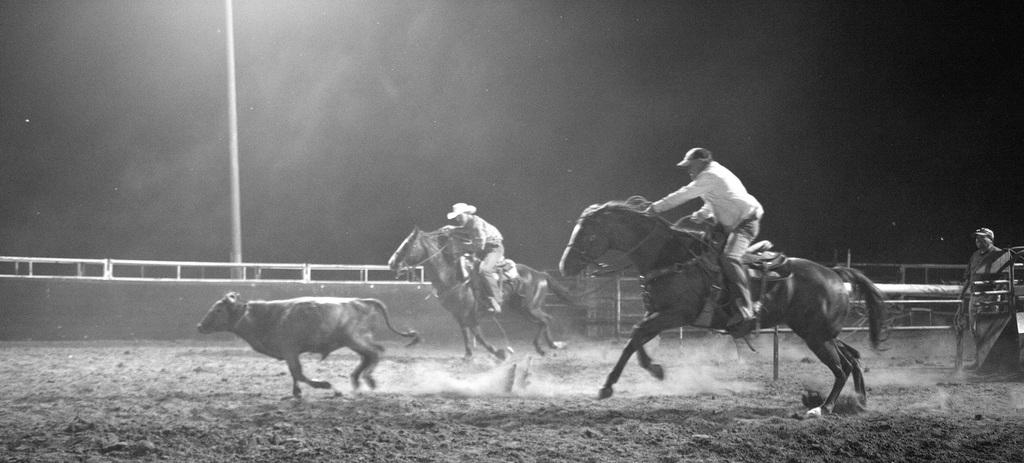What are the two persons in the image doing? The two persons in the image are riding horses. What can be seen beneath the horses and riders? The ground is visible in the image. Is there anyone else present in the image besides the riders? Yes, there is one person standing and watching. What else is happening on the ground in the image? There is a cow running on the ground in the image. What organization is responsible for the invention of the horses in the image? There is no mention of an organization or invention in the image; it simply shows two persons riding horses and a cow running on the ground. 